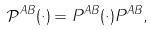<formula> <loc_0><loc_0><loc_500><loc_500>\mathcal { P } ^ { A B } ( \cdot ) = P ^ { A B } ( \cdot ) P ^ { A B } ,</formula> 